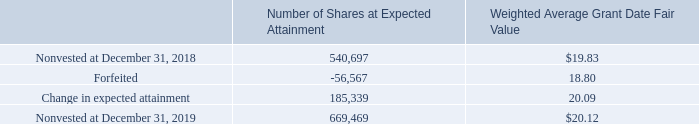Long-term Incentive Program Performance Share Awards
During the year ended December 31, 2017, pursuant to the Company’s 2016 Incentive Plan, the Company granted long-term incentive program performance share awards (“LTIP performance shares”). These LTIP performance shares are earned, if at all, based upon the achievement, over a specified period that must not be less than one year and is typically a three-year performance period, of performance goals related to (i) the compound annual growth over the performance period in the sales for the Company as determined by the Company, and (ii) the cumulative operating income or EBITDA over the performance period as determined by the Company. Up to 200% of the LTIP performance shares may be earned upon achievement of performance goals equal to or exceeding the maximum target levels for the performance goals over the performance period. On a quarterly basis, management
A summary of the nonvested LTIP performance shares is as follows:
During the year ended December 31, 2019, the Company revised the expected attainment rates for outstanding LTIP performance shares due to changes in forecasted sales and operating income, resulting in additional stock-based compensation expense of approximately $3.7 million.
What was the additional stock-based compensation expense in 2019?
Answer scale should be: million. $3.7 million. What was the number of nonvested shares at expected attainment in 2019? 669,469. What was the number of nonvested shares at expected attainment in 2018? 540,697. What was the change in nonvested shares at expected attainment between 2018 and 2019? 669,469-540,697
Answer: 128772. What was the percentage change in nonvested shares at expected attainment between 2018 and 2019?
Answer scale should be: percent. (669,469-540,697)/540,697
Answer: 23.82. What is the difference in Weighted Average Grant Date Fair Value between nonvested shares and forfeited shares in 2018? $19.83-18.80
Answer: 1.03. 